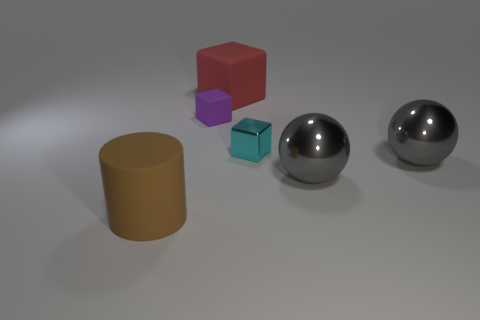How many gray things are large rubber cylinders or shiny objects?
Give a very brief answer. 2. How many brown cylinders have the same size as the red cube?
Your answer should be compact. 1. There is a big object that is left of the tiny cyan cube and behind the brown thing; what color is it?
Give a very brief answer. Red. Are there more tiny purple objects that are right of the purple block than balls?
Your answer should be compact. No. Are any gray rubber cylinders visible?
Make the answer very short. No. Is the color of the cylinder the same as the large cube?
Your response must be concise. No. What number of big things are red cubes or brown rubber cylinders?
Your answer should be compact. 2. Are there any other things that have the same color as the metal cube?
Your answer should be very brief. No. What shape is the brown thing that is the same material as the large red object?
Offer a terse response. Cylinder. There is a red matte cube that is behind the cyan cube; what is its size?
Your answer should be compact. Large. 